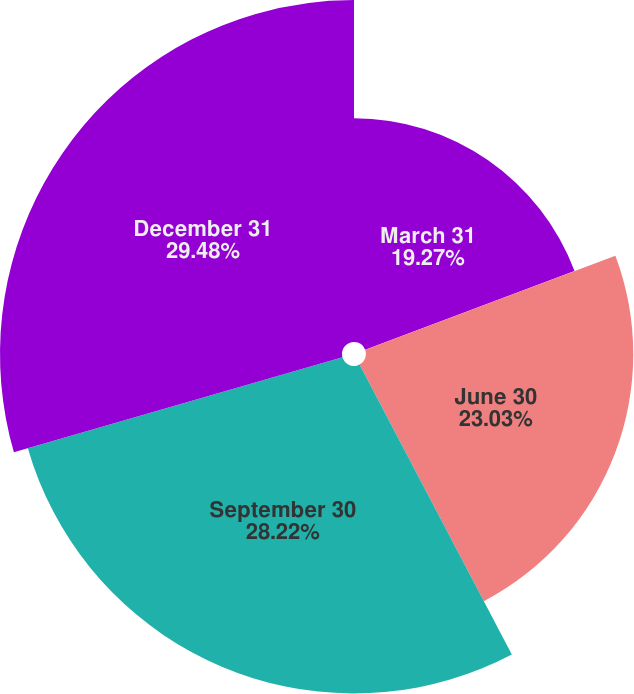<chart> <loc_0><loc_0><loc_500><loc_500><pie_chart><fcel>March 31<fcel>June 30<fcel>September 30<fcel>December 31<nl><fcel>19.27%<fcel>23.03%<fcel>28.22%<fcel>29.47%<nl></chart> 